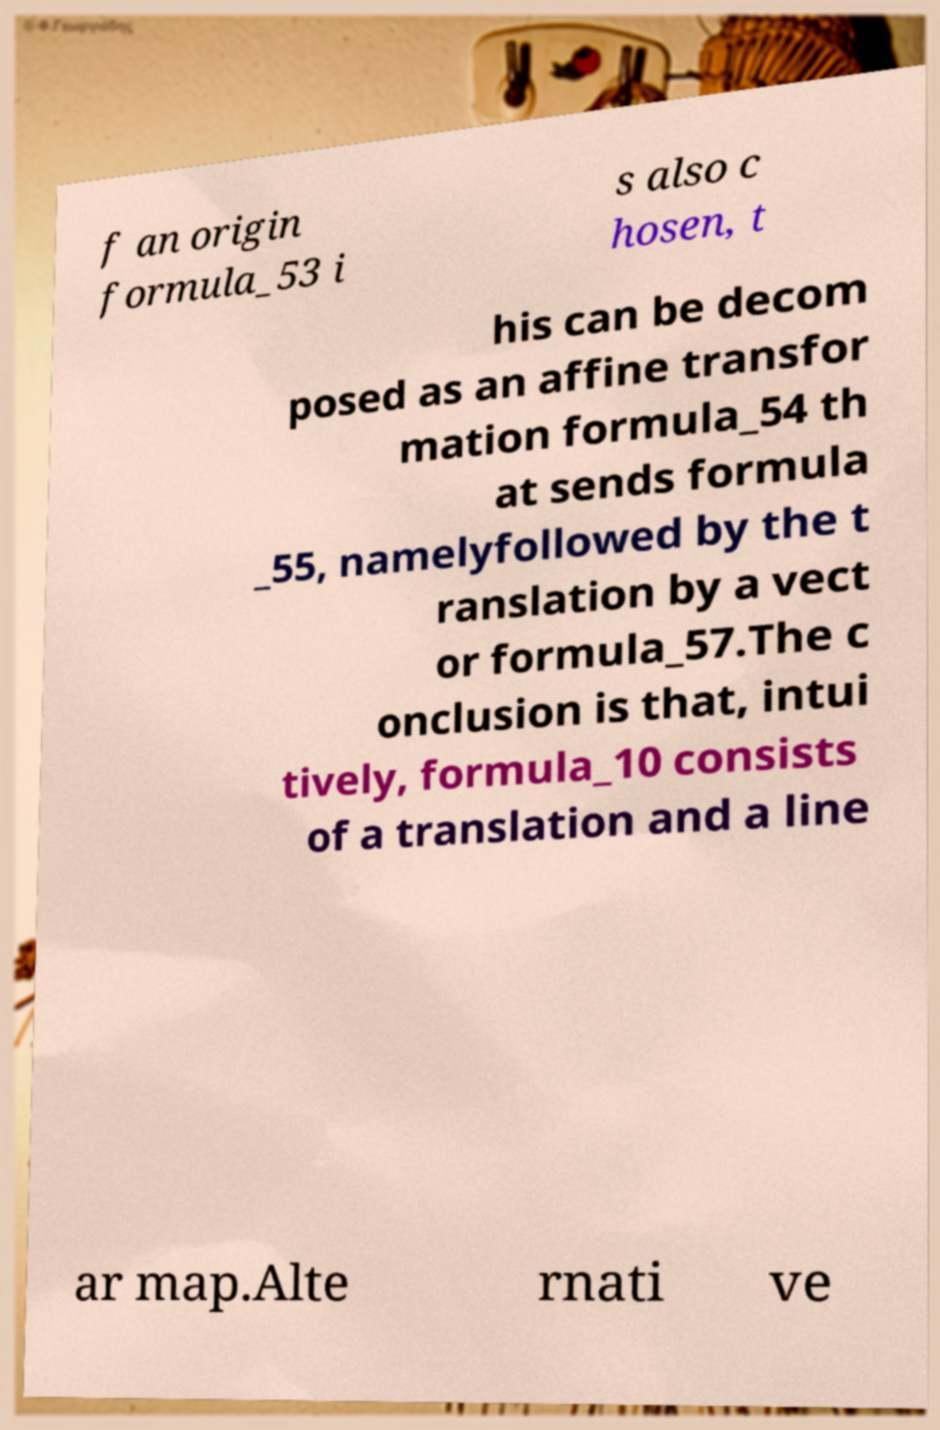Can you accurately transcribe the text from the provided image for me? f an origin formula_53 i s also c hosen, t his can be decom posed as an affine transfor mation formula_54 th at sends formula _55, namelyfollowed by the t ranslation by a vect or formula_57.The c onclusion is that, intui tively, formula_10 consists of a translation and a line ar map.Alte rnati ve 